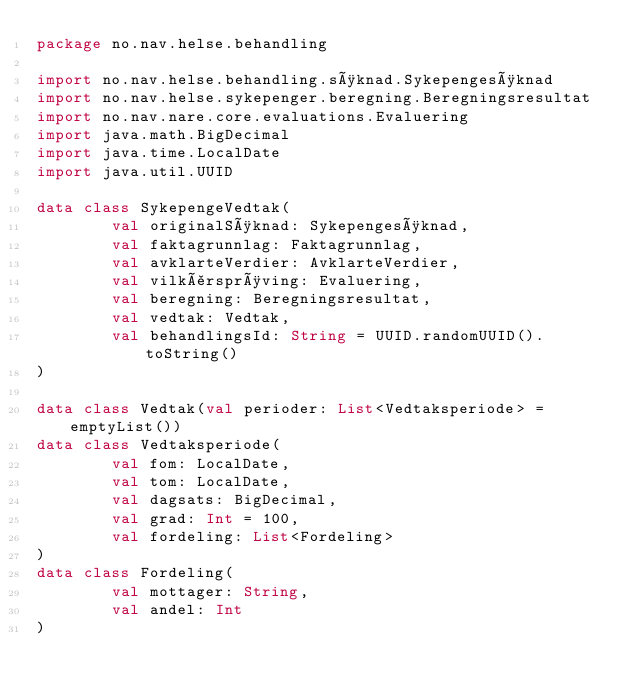Convert code to text. <code><loc_0><loc_0><loc_500><loc_500><_Kotlin_>package no.nav.helse.behandling

import no.nav.helse.behandling.søknad.Sykepengesøknad
import no.nav.helse.sykepenger.beregning.Beregningsresultat
import no.nav.nare.core.evaluations.Evaluering
import java.math.BigDecimal
import java.time.LocalDate
import java.util.UUID

data class SykepengeVedtak(
        val originalSøknad: Sykepengesøknad,
        val faktagrunnlag: Faktagrunnlag,
        val avklarteVerdier: AvklarteVerdier,
        val vilkårsprøving: Evaluering,
        val beregning: Beregningsresultat,
        val vedtak: Vedtak,
        val behandlingsId: String = UUID.randomUUID().toString()
)

data class Vedtak(val perioder: List<Vedtaksperiode> = emptyList())
data class Vedtaksperiode(
        val fom: LocalDate,
        val tom: LocalDate,
        val dagsats: BigDecimal,
        val grad: Int = 100,
        val fordeling: List<Fordeling>
)
data class Fordeling(
        val mottager: String,
        val andel: Int
)
</code> 